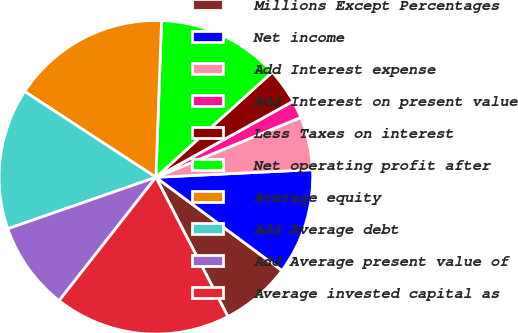Convert chart. <chart><loc_0><loc_0><loc_500><loc_500><pie_chart><fcel>Millions Except Percentages<fcel>Net income<fcel>Add Interest expense<fcel>Add Interest on present value<fcel>Less Taxes on interest<fcel>Net operating profit after<fcel>Average equity<fcel>Add Average debt<fcel>Add Average present value of<fcel>Average invested capital as<nl><fcel>7.27%<fcel>10.91%<fcel>5.46%<fcel>1.82%<fcel>3.64%<fcel>12.73%<fcel>16.36%<fcel>14.54%<fcel>9.09%<fcel>18.18%<nl></chart> 